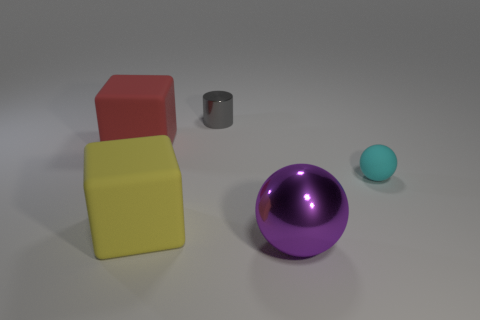Which objects in the image could you describe as 'geometrically perfect'? The objects that could be described as 'geometrically perfect' are the red cube, yellow cube, gray cylinder, purple ball, and the small teal ball. Each of these objects has a clear and precise geometric shape without any visible distortions. 